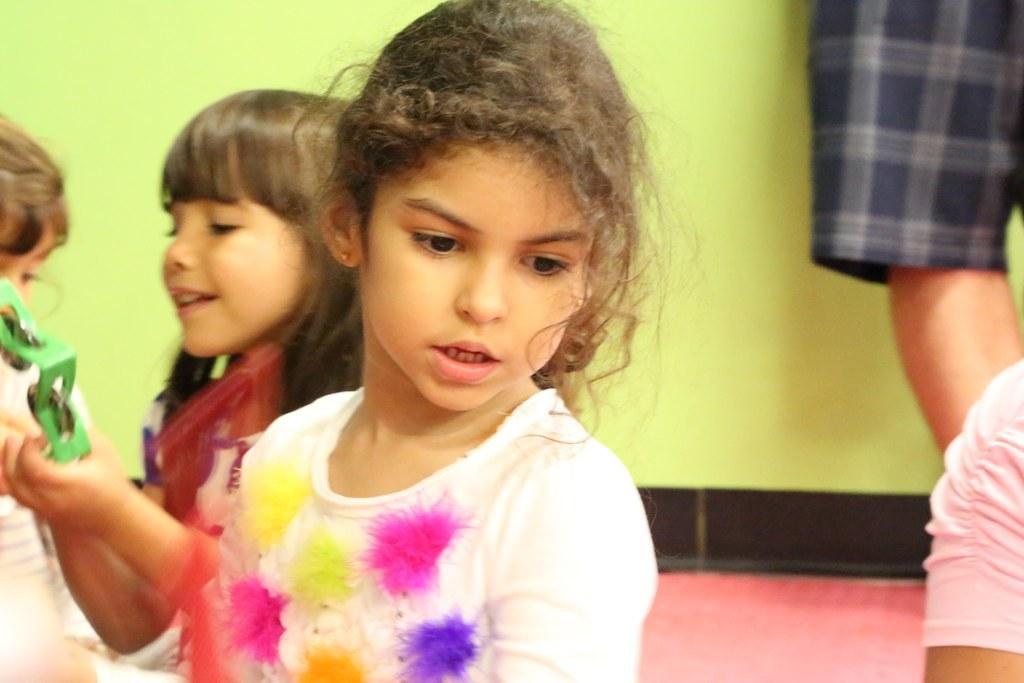Can you describe this image briefly? This image consists of many people. In the front, we can see a girl wearing a white dress is sitting on the floor. On the left, there is another girl holding a musical instrument. At the bottom, there is a floor. In the background, the wall is in yellow color. 